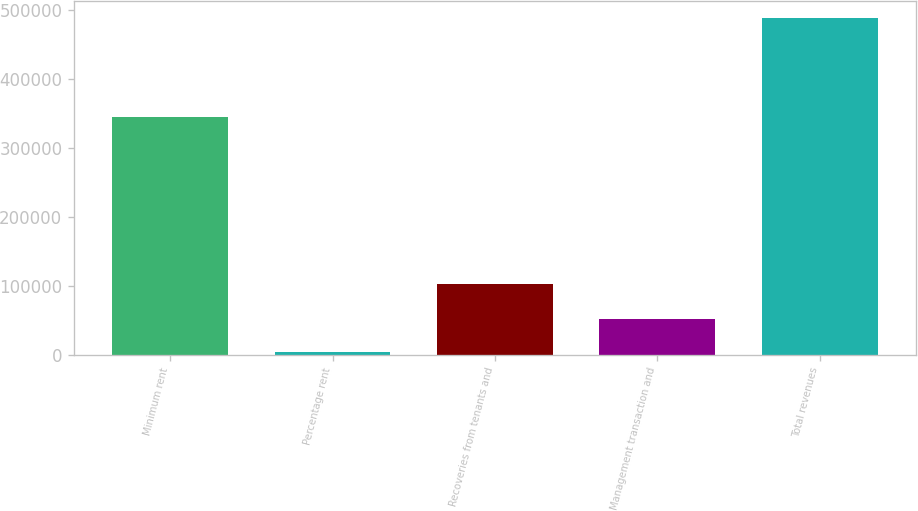Convert chart to OTSL. <chart><loc_0><loc_0><loc_500><loc_500><bar_chart><fcel>Minimum rent<fcel>Percentage rent<fcel>Recoveries from tenants and<fcel>Management transaction and<fcel>Total revenues<nl><fcel>344709<fcel>3585<fcel>101490<fcel>52033.8<fcel>488073<nl></chart> 